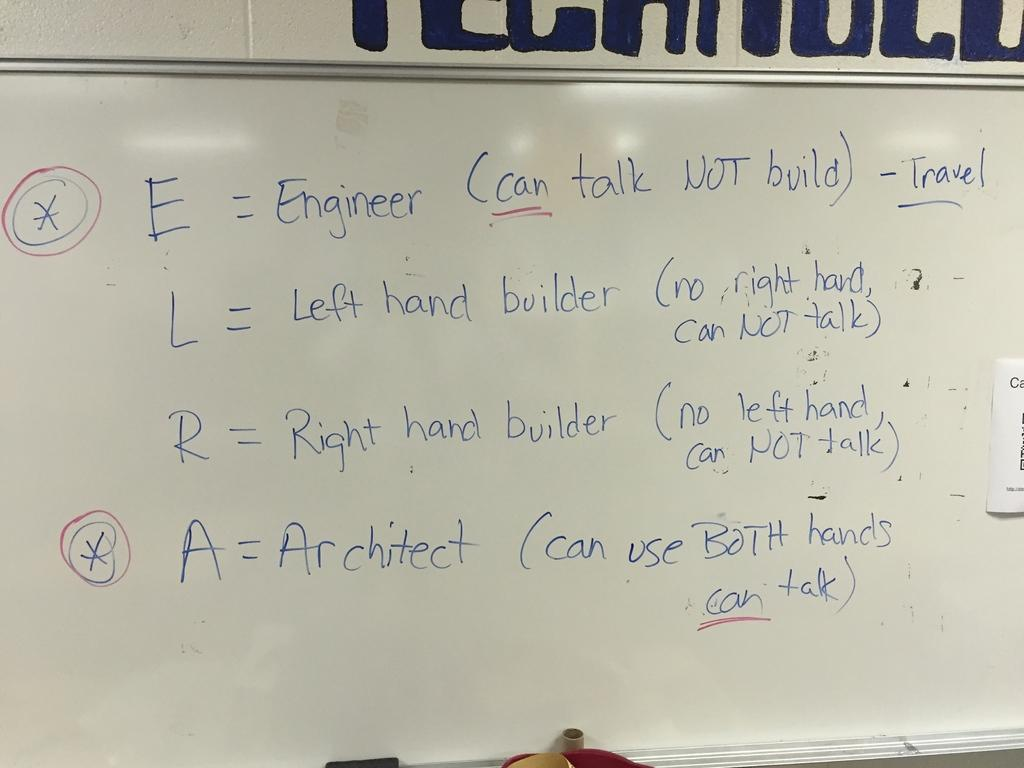Provide a one-sentence caption for the provided image. a close up of a white board with words E = Engineer on it. 